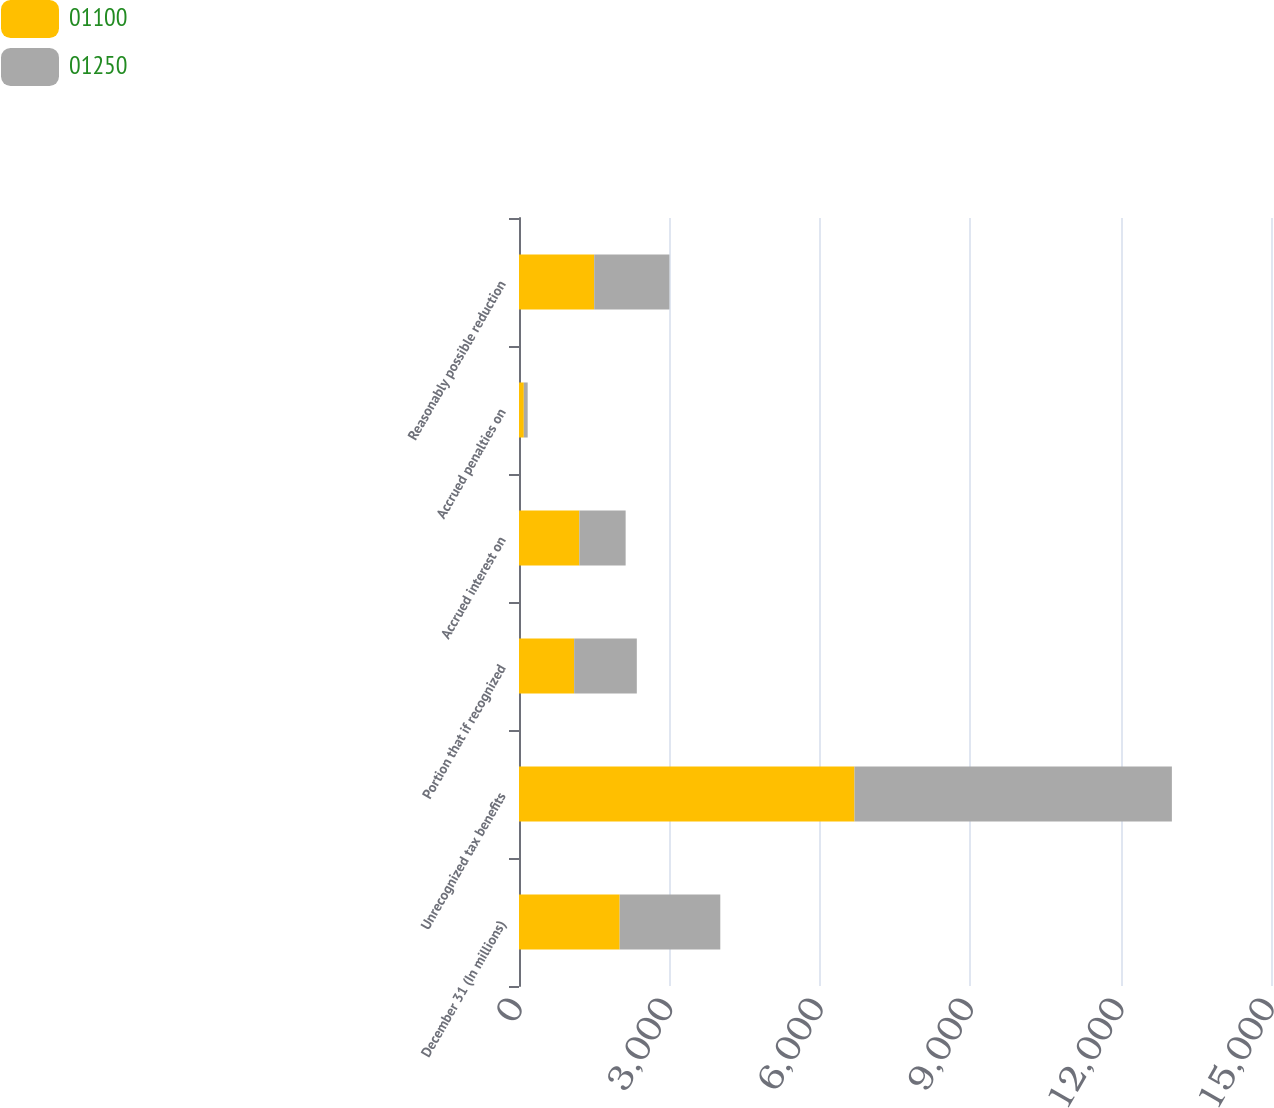Convert chart. <chart><loc_0><loc_0><loc_500><loc_500><stacked_bar_chart><ecel><fcel>December 31 (In millions)<fcel>Unrecognized tax benefits<fcel>Portion that if recognized<fcel>Accrued interest on<fcel>Accrued penalties on<fcel>Reasonably possible reduction<nl><fcel>1100<fcel>2008<fcel>6692<fcel>1100<fcel>1204<fcel>96<fcel>1500<nl><fcel>1250<fcel>2007<fcel>6331<fcel>1250<fcel>923<fcel>77<fcel>1500<nl></chart> 